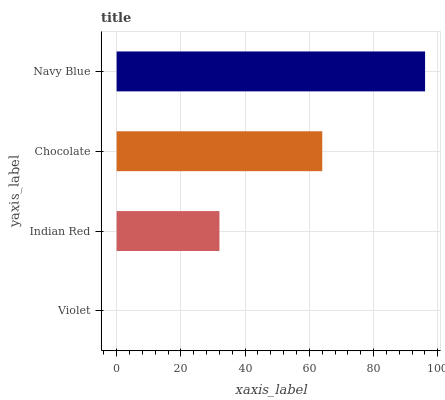Is Violet the minimum?
Answer yes or no. Yes. Is Navy Blue the maximum?
Answer yes or no. Yes. Is Indian Red the minimum?
Answer yes or no. No. Is Indian Red the maximum?
Answer yes or no. No. Is Indian Red greater than Violet?
Answer yes or no. Yes. Is Violet less than Indian Red?
Answer yes or no. Yes. Is Violet greater than Indian Red?
Answer yes or no. No. Is Indian Red less than Violet?
Answer yes or no. No. Is Chocolate the high median?
Answer yes or no. Yes. Is Indian Red the low median?
Answer yes or no. Yes. Is Navy Blue the high median?
Answer yes or no. No. Is Chocolate the low median?
Answer yes or no. No. 